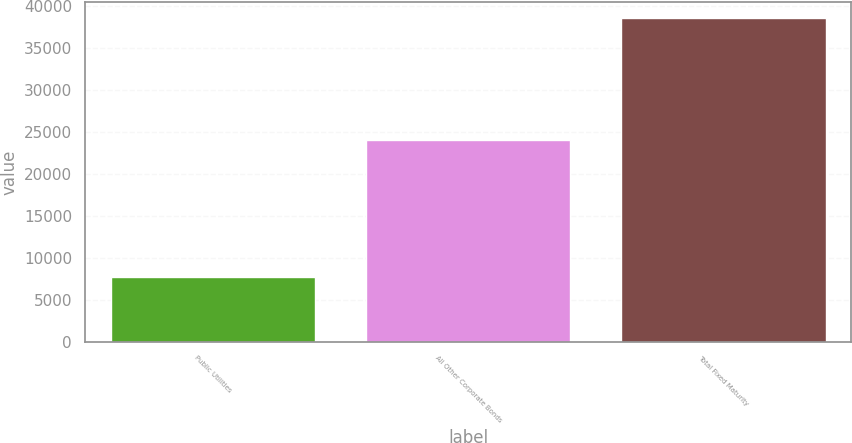Convert chart. <chart><loc_0><loc_0><loc_500><loc_500><bar_chart><fcel>Public Utilities<fcel>All Other Corporate Bonds<fcel>Total Fixed Maturity<nl><fcel>7687.2<fcel>23992.8<fcel>38546.4<nl></chart> 